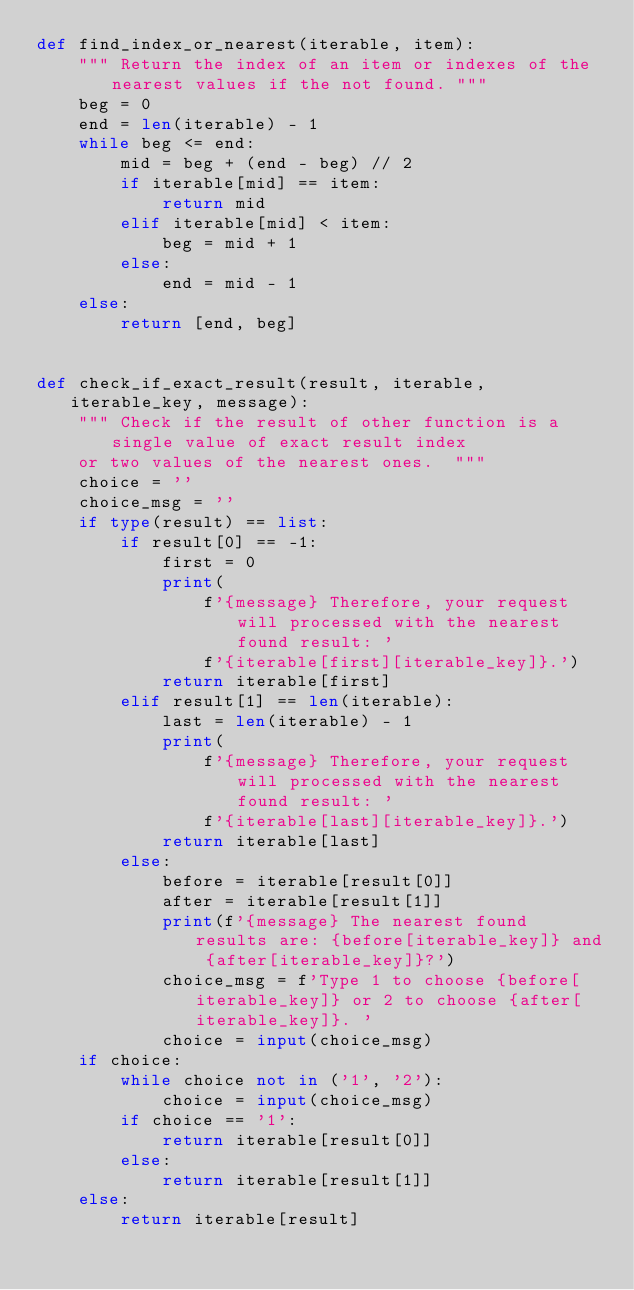<code> <loc_0><loc_0><loc_500><loc_500><_Python_>def find_index_or_nearest(iterable, item):
    """ Return the index of an item or indexes of the nearest values if the not found. """
    beg = 0
    end = len(iterable) - 1
    while beg <= end:
        mid = beg + (end - beg) // 2
        if iterable[mid] == item:
            return mid
        elif iterable[mid] < item:
            beg = mid + 1
        else:
            end = mid - 1
    else:
        return [end, beg]


def check_if_exact_result(result, iterable, iterable_key, message):
    """ Check if the result of other function is a single value of exact result index
    or two values of the nearest ones.  """
    choice = ''
    choice_msg = ''
    if type(result) == list:
        if result[0] == -1:
            first = 0
            print(
                f'{message} Therefore, your request will processed with the nearest found result: '
                f'{iterable[first][iterable_key]}.')
            return iterable[first]
        elif result[1] == len(iterable):
            last = len(iterable) - 1
            print(
                f'{message} Therefore, your request will processed with the nearest found result: '
                f'{iterable[last][iterable_key]}.')
            return iterable[last]
        else:
            before = iterable[result[0]]
            after = iterable[result[1]]
            print(f'{message} The nearest found results are: {before[iterable_key]} and {after[iterable_key]}?')
            choice_msg = f'Type 1 to choose {before[iterable_key]} or 2 to choose {after[iterable_key]}. '
            choice = input(choice_msg)
    if choice:
        while choice not in ('1', '2'):
            choice = input(choice_msg)
        if choice == '1':
            return iterable[result[0]]
        else:
            return iterable[result[1]]
    else:
        return iterable[result]
</code> 